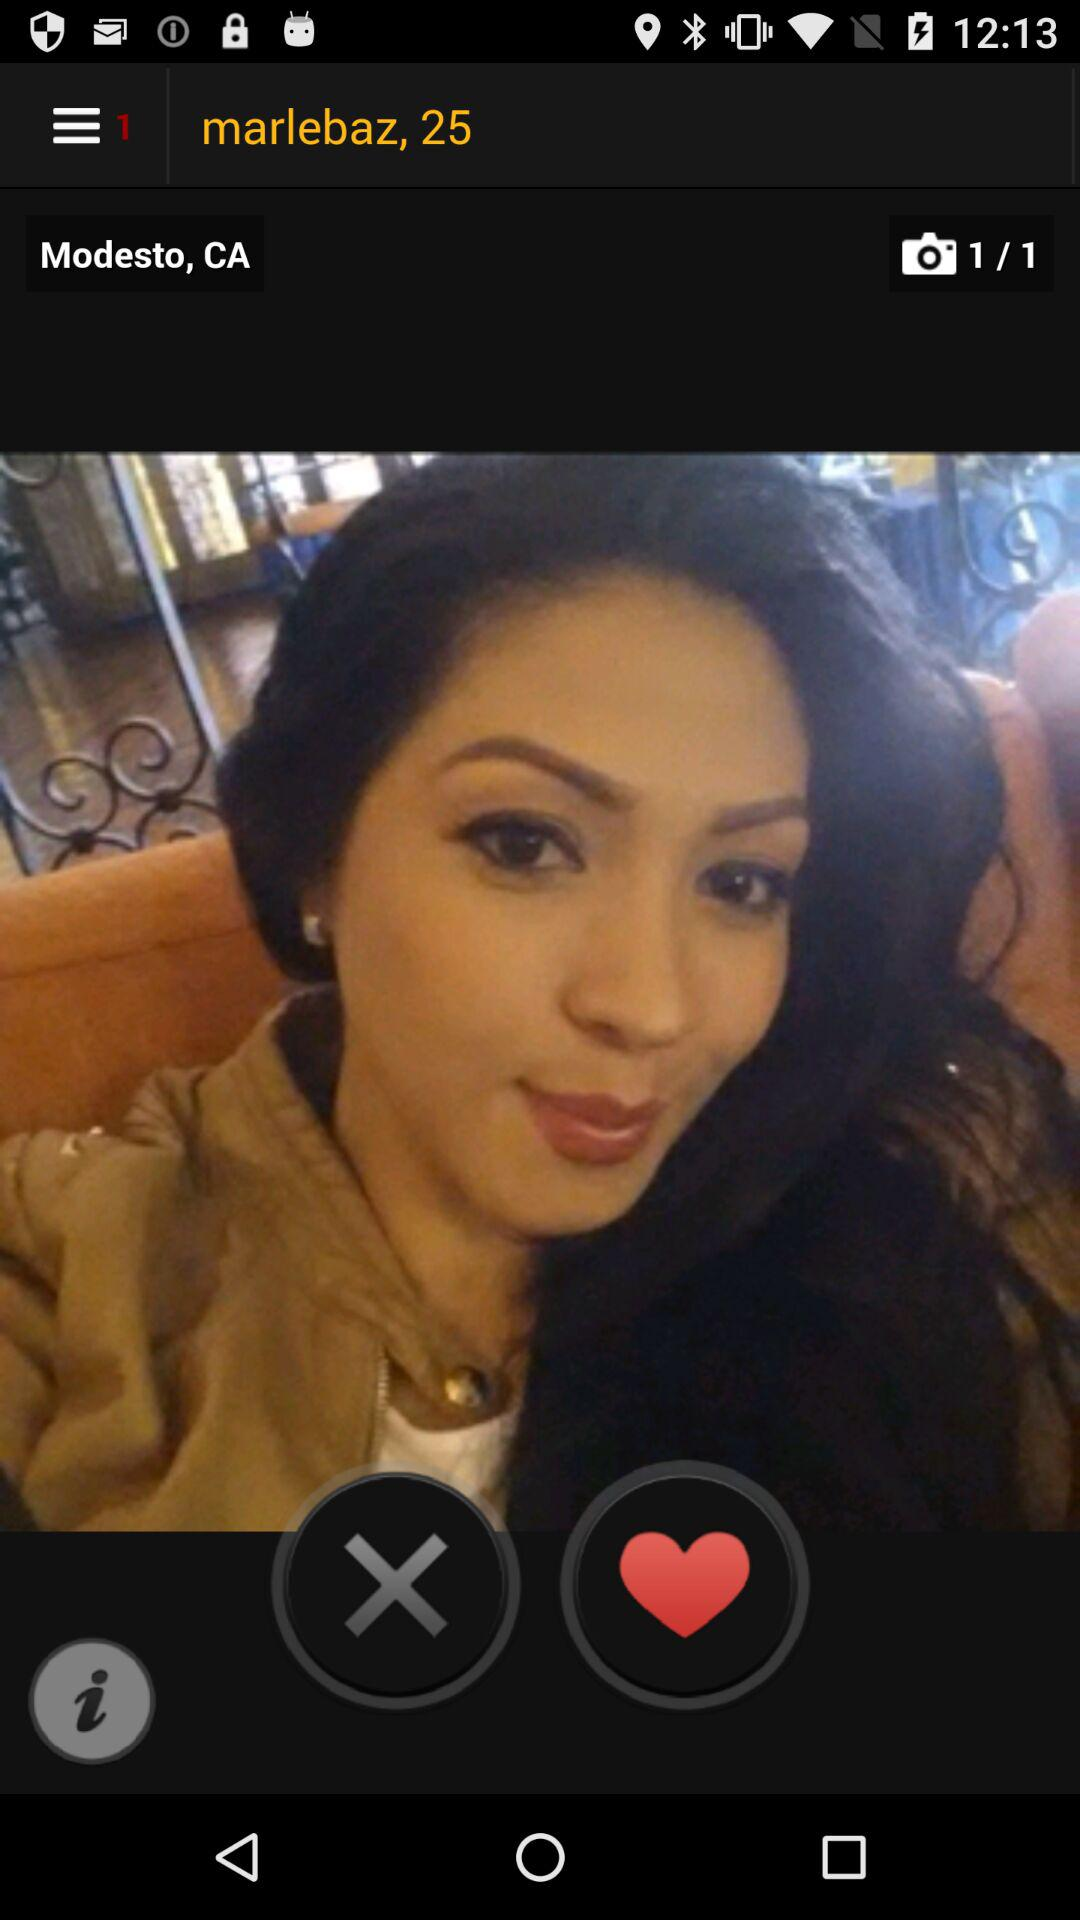What is the location? The location is Modesto, CA. 